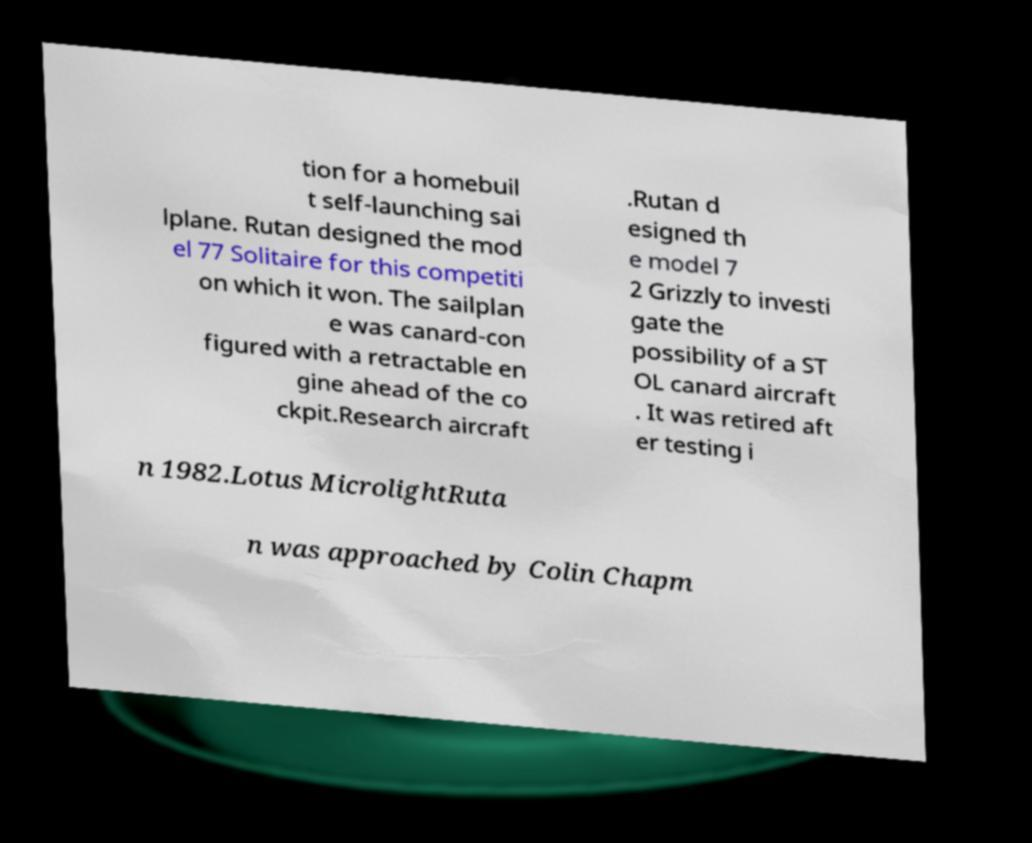For documentation purposes, I need the text within this image transcribed. Could you provide that? tion for a homebuil t self-launching sai lplane. Rutan designed the mod el 77 Solitaire for this competiti on which it won. The sailplan e was canard-con figured with a retractable en gine ahead of the co ckpit.Research aircraft .Rutan d esigned th e model 7 2 Grizzly to investi gate the possibility of a ST OL canard aircraft . It was retired aft er testing i n 1982.Lotus MicrolightRuta n was approached by Colin Chapm 